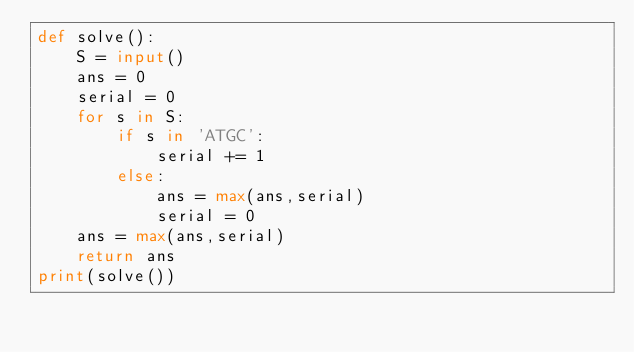<code> <loc_0><loc_0><loc_500><loc_500><_Python_>def solve():
    S = input()
    ans = 0
    serial = 0
    for s in S:
        if s in 'ATGC':
            serial += 1
        else:
            ans = max(ans,serial)
            serial = 0
    ans = max(ans,serial)
    return ans
print(solve())</code> 